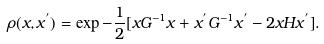<formula> <loc_0><loc_0><loc_500><loc_500>\rho ( x , x ^ { ^ { \prime } } ) = \exp { - \frac { 1 } { 2 } [ x G ^ { - 1 } x + x ^ { ^ { \prime } } G ^ { - 1 } x ^ { ^ { \prime } } - 2 x H x ^ { ^ { \prime } } ] } .</formula> 